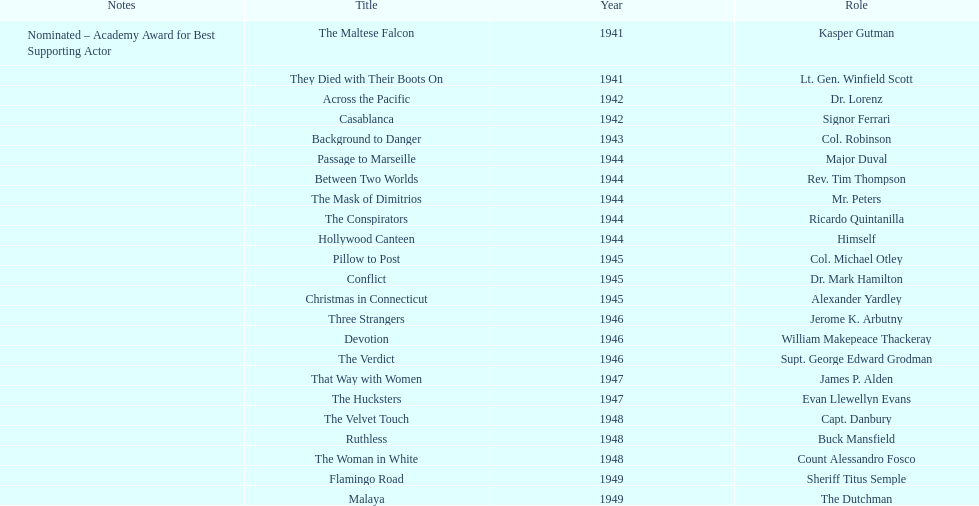What movies did greenstreet act for in 1946? Three Strangers, Devotion, The Verdict. 